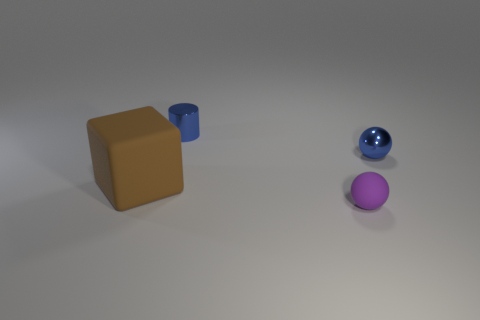Is there any other thing that is the same shape as the brown thing?
Your answer should be compact. No. Is there a small purple ball that has the same material as the big brown block?
Provide a succinct answer. Yes. How many cubes are tiny blue metallic things or small purple matte objects?
Give a very brief answer. 0. Is there a small metal cylinder that is behind the object in front of the brown rubber object?
Provide a short and direct response. Yes. Is the number of large cyan cylinders less than the number of big brown rubber blocks?
Your answer should be compact. Yes. How many other things have the same shape as the tiny purple rubber thing?
Your answer should be compact. 1. How many brown objects are large objects or balls?
Provide a short and direct response. 1. What size is the metallic object right of the matte object to the right of the big rubber thing?
Provide a short and direct response. Small. There is another small thing that is the same shape as the purple thing; what is it made of?
Make the answer very short. Metal. What number of gray metal balls are the same size as the blue shiny cylinder?
Your answer should be very brief. 0. 